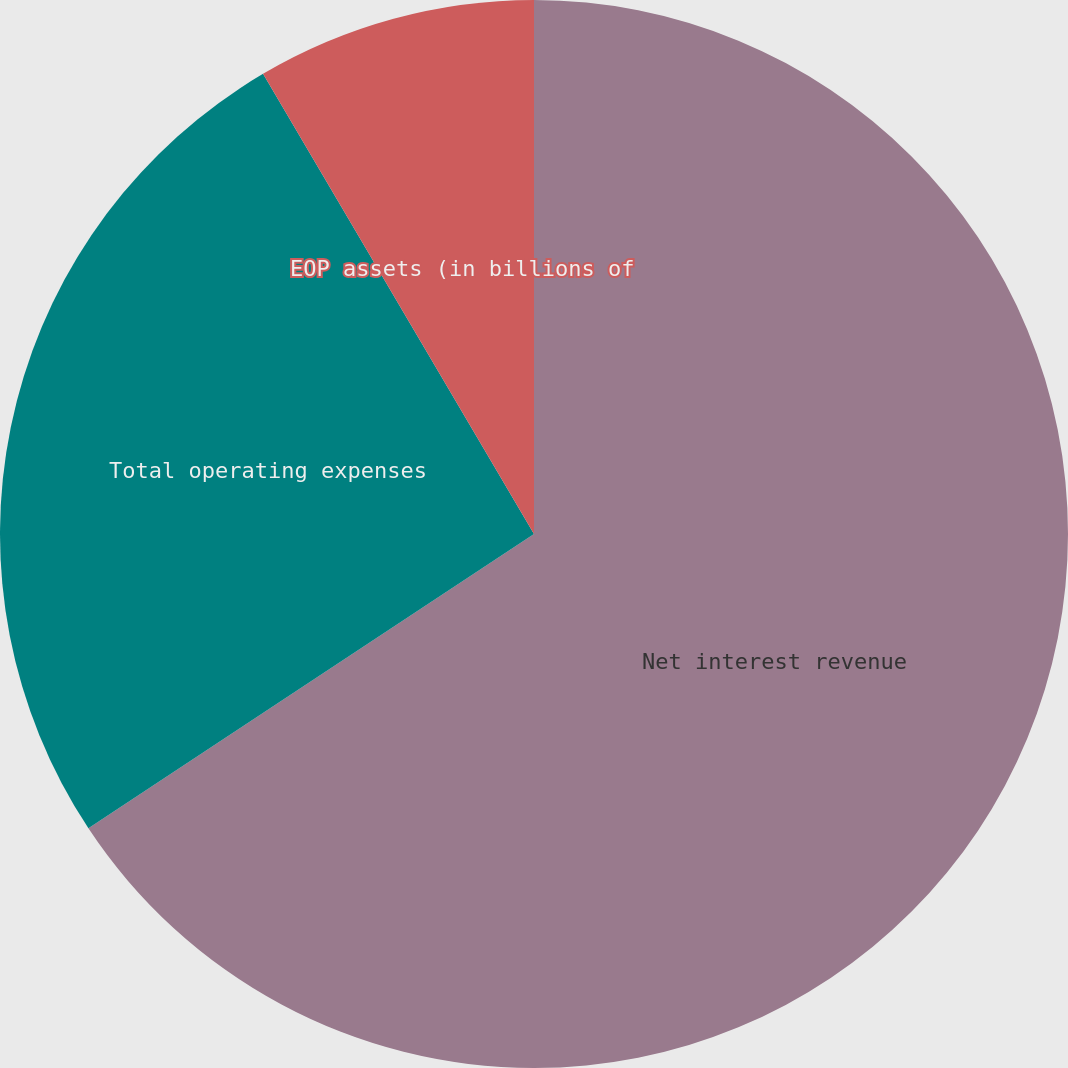Convert chart. <chart><loc_0><loc_0><loc_500><loc_500><pie_chart><fcel>Net interest revenue<fcel>Total operating expenses<fcel>EOP assets (in billions of<nl><fcel>65.71%<fcel>25.82%<fcel>8.47%<nl></chart> 